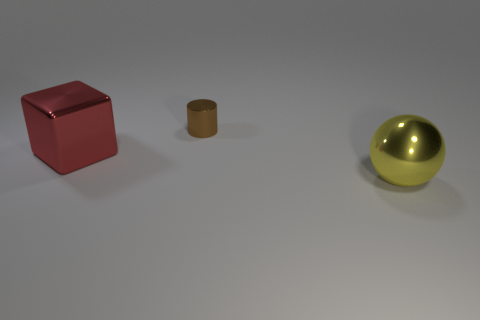Can you describe the lighting and shadows in the scene? The objects in the scene are lit from the upper left, as indicated by the shadows that extend towards the bottom right of the image. The lighting is diffused, creating soft shadows with a gradual transition from light to dark, which suggests an indoor setting with ambient light sources or possibly a cloudy day if it were an outdoor setting. 